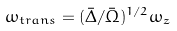Convert formula to latex. <formula><loc_0><loc_0><loc_500><loc_500>\omega _ { t r a n s } = ( \bar { \Delta } / \bar { \Omega } ) ^ { 1 / 2 } \omega _ { z }</formula> 